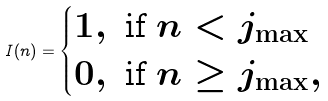Convert formula to latex. <formula><loc_0><loc_0><loc_500><loc_500>I ( n ) = \begin{cases} 1 , \text { if } n < j _ { \max } \\ 0 , \text { if } n \geq j _ { \max } , \end{cases}</formula> 